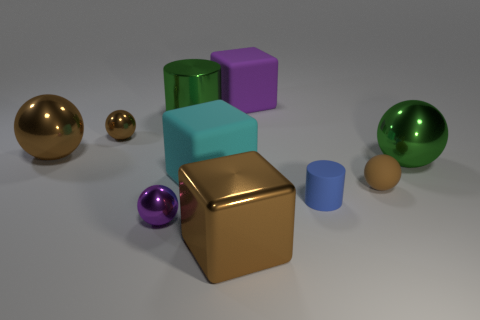If these were part of a game, what might the rules be? If these objects were part of a game, the rules might include sorting or stacking the objects by size, color, or material. Alternatively, the spheres could be used in a bowling-type game where the goal is to knock over the cubes, using the golden cube as a 'kingpin' with extra points if it's knocked over last. 